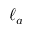<formula> <loc_0><loc_0><loc_500><loc_500>\ell _ { a }</formula> 